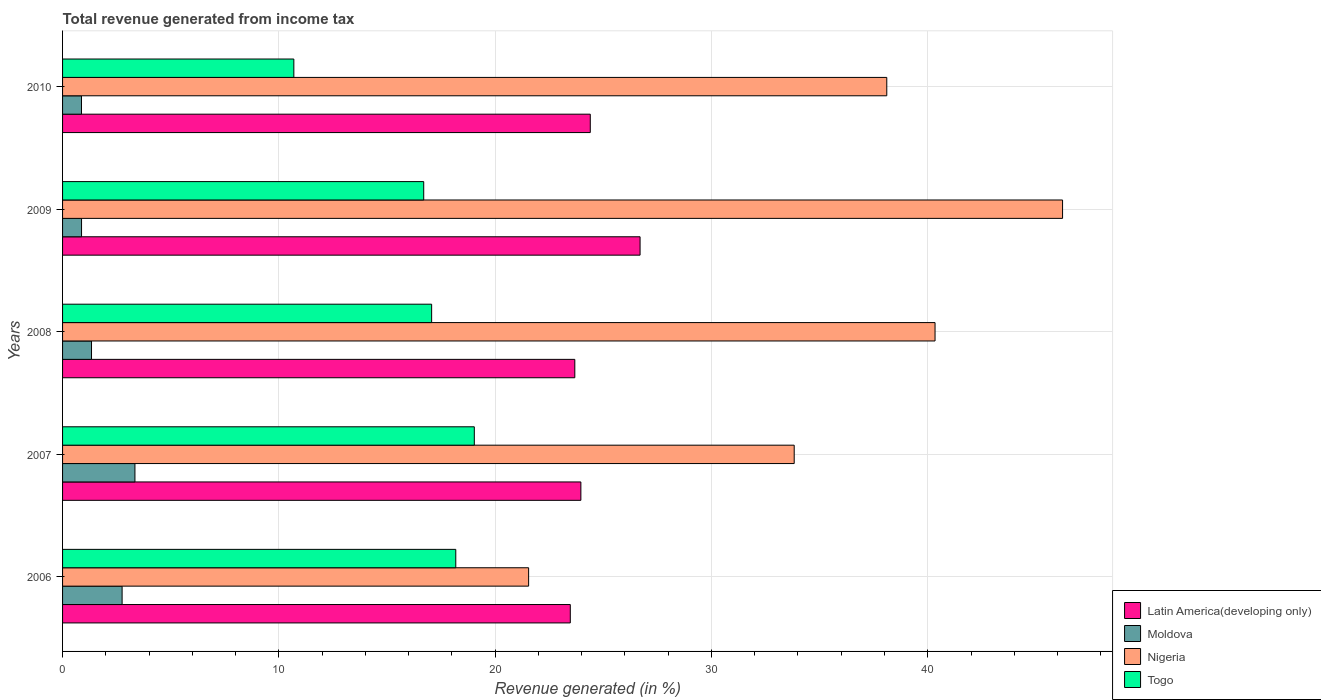How many groups of bars are there?
Your answer should be very brief. 5. Are the number of bars per tick equal to the number of legend labels?
Your answer should be compact. Yes. Are the number of bars on each tick of the Y-axis equal?
Your answer should be very brief. Yes. What is the label of the 1st group of bars from the top?
Keep it short and to the point. 2010. In how many cases, is the number of bars for a given year not equal to the number of legend labels?
Keep it short and to the point. 0. What is the total revenue generated in Nigeria in 2007?
Offer a terse response. 33.83. Across all years, what is the maximum total revenue generated in Latin America(developing only)?
Your answer should be very brief. 26.7. Across all years, what is the minimum total revenue generated in Togo?
Ensure brevity in your answer.  10.69. In which year was the total revenue generated in Moldova maximum?
Ensure brevity in your answer.  2007. What is the total total revenue generated in Moldova in the graph?
Provide a succinct answer. 9.19. What is the difference between the total revenue generated in Latin America(developing only) in 2007 and that in 2008?
Make the answer very short. 0.28. What is the difference between the total revenue generated in Moldova in 2008 and the total revenue generated in Togo in 2007?
Make the answer very short. -17.7. What is the average total revenue generated in Nigeria per year?
Offer a very short reply. 36.01. In the year 2006, what is the difference between the total revenue generated in Moldova and total revenue generated in Latin America(developing only)?
Make the answer very short. -20.72. In how many years, is the total revenue generated in Nigeria greater than 26 %?
Ensure brevity in your answer.  4. What is the ratio of the total revenue generated in Moldova in 2006 to that in 2007?
Offer a very short reply. 0.82. What is the difference between the highest and the second highest total revenue generated in Moldova?
Ensure brevity in your answer.  0.59. What is the difference between the highest and the lowest total revenue generated in Nigeria?
Offer a terse response. 24.69. Is it the case that in every year, the sum of the total revenue generated in Togo and total revenue generated in Latin America(developing only) is greater than the sum of total revenue generated in Moldova and total revenue generated in Nigeria?
Offer a very short reply. No. What does the 4th bar from the top in 2008 represents?
Ensure brevity in your answer.  Latin America(developing only). What does the 1st bar from the bottom in 2009 represents?
Ensure brevity in your answer.  Latin America(developing only). Is it the case that in every year, the sum of the total revenue generated in Moldova and total revenue generated in Nigeria is greater than the total revenue generated in Latin America(developing only)?
Offer a very short reply. Yes. How many bars are there?
Offer a very short reply. 20. Are all the bars in the graph horizontal?
Keep it short and to the point. Yes. Does the graph contain any zero values?
Provide a succinct answer. No. Where does the legend appear in the graph?
Keep it short and to the point. Bottom right. What is the title of the graph?
Your answer should be compact. Total revenue generated from income tax. Does "West Bank and Gaza" appear as one of the legend labels in the graph?
Make the answer very short. No. What is the label or title of the X-axis?
Offer a terse response. Revenue generated (in %). What is the label or title of the Y-axis?
Keep it short and to the point. Years. What is the Revenue generated (in %) of Latin America(developing only) in 2006?
Provide a short and direct response. 23.47. What is the Revenue generated (in %) in Moldova in 2006?
Offer a very short reply. 2.75. What is the Revenue generated (in %) in Nigeria in 2006?
Keep it short and to the point. 21.55. What is the Revenue generated (in %) of Togo in 2006?
Your answer should be very brief. 18.18. What is the Revenue generated (in %) in Latin America(developing only) in 2007?
Offer a terse response. 23.96. What is the Revenue generated (in %) in Moldova in 2007?
Ensure brevity in your answer.  3.35. What is the Revenue generated (in %) of Nigeria in 2007?
Your answer should be very brief. 33.83. What is the Revenue generated (in %) of Togo in 2007?
Offer a very short reply. 19.04. What is the Revenue generated (in %) of Latin America(developing only) in 2008?
Your response must be concise. 23.68. What is the Revenue generated (in %) in Moldova in 2008?
Your response must be concise. 1.34. What is the Revenue generated (in %) in Nigeria in 2008?
Make the answer very short. 40.34. What is the Revenue generated (in %) in Togo in 2008?
Offer a terse response. 17.06. What is the Revenue generated (in %) of Latin America(developing only) in 2009?
Your answer should be very brief. 26.7. What is the Revenue generated (in %) of Moldova in 2009?
Keep it short and to the point. 0.88. What is the Revenue generated (in %) in Nigeria in 2009?
Your answer should be very brief. 46.23. What is the Revenue generated (in %) of Togo in 2009?
Make the answer very short. 16.7. What is the Revenue generated (in %) in Latin America(developing only) in 2010?
Offer a very short reply. 24.4. What is the Revenue generated (in %) of Moldova in 2010?
Your response must be concise. 0.87. What is the Revenue generated (in %) of Nigeria in 2010?
Ensure brevity in your answer.  38.11. What is the Revenue generated (in %) in Togo in 2010?
Offer a terse response. 10.69. Across all years, what is the maximum Revenue generated (in %) in Latin America(developing only)?
Ensure brevity in your answer.  26.7. Across all years, what is the maximum Revenue generated (in %) in Moldova?
Provide a short and direct response. 3.35. Across all years, what is the maximum Revenue generated (in %) of Nigeria?
Provide a succinct answer. 46.23. Across all years, what is the maximum Revenue generated (in %) in Togo?
Give a very brief answer. 19.04. Across all years, what is the minimum Revenue generated (in %) in Latin America(developing only)?
Provide a succinct answer. 23.47. Across all years, what is the minimum Revenue generated (in %) in Moldova?
Your response must be concise. 0.87. Across all years, what is the minimum Revenue generated (in %) in Nigeria?
Make the answer very short. 21.55. Across all years, what is the minimum Revenue generated (in %) of Togo?
Offer a very short reply. 10.69. What is the total Revenue generated (in %) of Latin America(developing only) in the graph?
Your response must be concise. 122.22. What is the total Revenue generated (in %) of Moldova in the graph?
Provide a short and direct response. 9.19. What is the total Revenue generated (in %) of Nigeria in the graph?
Offer a very short reply. 180.05. What is the total Revenue generated (in %) in Togo in the graph?
Provide a succinct answer. 81.67. What is the difference between the Revenue generated (in %) in Latin America(developing only) in 2006 and that in 2007?
Provide a succinct answer. -0.49. What is the difference between the Revenue generated (in %) in Moldova in 2006 and that in 2007?
Offer a terse response. -0.59. What is the difference between the Revenue generated (in %) of Nigeria in 2006 and that in 2007?
Your answer should be compact. -12.28. What is the difference between the Revenue generated (in %) of Togo in 2006 and that in 2007?
Offer a very short reply. -0.86. What is the difference between the Revenue generated (in %) of Latin America(developing only) in 2006 and that in 2008?
Ensure brevity in your answer.  -0.21. What is the difference between the Revenue generated (in %) of Moldova in 2006 and that in 2008?
Make the answer very short. 1.41. What is the difference between the Revenue generated (in %) in Nigeria in 2006 and that in 2008?
Offer a very short reply. -18.79. What is the difference between the Revenue generated (in %) of Togo in 2006 and that in 2008?
Offer a terse response. 1.12. What is the difference between the Revenue generated (in %) in Latin America(developing only) in 2006 and that in 2009?
Your response must be concise. -3.23. What is the difference between the Revenue generated (in %) in Moldova in 2006 and that in 2009?
Keep it short and to the point. 1.88. What is the difference between the Revenue generated (in %) in Nigeria in 2006 and that in 2009?
Provide a succinct answer. -24.69. What is the difference between the Revenue generated (in %) of Togo in 2006 and that in 2009?
Your answer should be very brief. 1.48. What is the difference between the Revenue generated (in %) of Latin America(developing only) in 2006 and that in 2010?
Offer a very short reply. -0.92. What is the difference between the Revenue generated (in %) of Moldova in 2006 and that in 2010?
Make the answer very short. 1.88. What is the difference between the Revenue generated (in %) in Nigeria in 2006 and that in 2010?
Make the answer very short. -16.56. What is the difference between the Revenue generated (in %) in Togo in 2006 and that in 2010?
Keep it short and to the point. 7.49. What is the difference between the Revenue generated (in %) of Latin America(developing only) in 2007 and that in 2008?
Make the answer very short. 0.28. What is the difference between the Revenue generated (in %) in Moldova in 2007 and that in 2008?
Give a very brief answer. 2.01. What is the difference between the Revenue generated (in %) of Nigeria in 2007 and that in 2008?
Keep it short and to the point. -6.51. What is the difference between the Revenue generated (in %) of Togo in 2007 and that in 2008?
Your response must be concise. 1.97. What is the difference between the Revenue generated (in %) of Latin America(developing only) in 2007 and that in 2009?
Your response must be concise. -2.74. What is the difference between the Revenue generated (in %) in Moldova in 2007 and that in 2009?
Your answer should be compact. 2.47. What is the difference between the Revenue generated (in %) in Nigeria in 2007 and that in 2009?
Offer a very short reply. -12.41. What is the difference between the Revenue generated (in %) of Togo in 2007 and that in 2009?
Your response must be concise. 2.34. What is the difference between the Revenue generated (in %) in Latin America(developing only) in 2007 and that in 2010?
Provide a short and direct response. -0.43. What is the difference between the Revenue generated (in %) of Moldova in 2007 and that in 2010?
Your response must be concise. 2.47. What is the difference between the Revenue generated (in %) of Nigeria in 2007 and that in 2010?
Offer a very short reply. -4.28. What is the difference between the Revenue generated (in %) of Togo in 2007 and that in 2010?
Provide a succinct answer. 8.34. What is the difference between the Revenue generated (in %) in Latin America(developing only) in 2008 and that in 2009?
Provide a short and direct response. -3.02. What is the difference between the Revenue generated (in %) of Moldova in 2008 and that in 2009?
Make the answer very short. 0.46. What is the difference between the Revenue generated (in %) of Nigeria in 2008 and that in 2009?
Offer a very short reply. -5.9. What is the difference between the Revenue generated (in %) of Togo in 2008 and that in 2009?
Give a very brief answer. 0.37. What is the difference between the Revenue generated (in %) of Latin America(developing only) in 2008 and that in 2010?
Your answer should be very brief. -0.72. What is the difference between the Revenue generated (in %) in Moldova in 2008 and that in 2010?
Offer a terse response. 0.46. What is the difference between the Revenue generated (in %) in Nigeria in 2008 and that in 2010?
Keep it short and to the point. 2.23. What is the difference between the Revenue generated (in %) in Togo in 2008 and that in 2010?
Provide a short and direct response. 6.37. What is the difference between the Revenue generated (in %) of Latin America(developing only) in 2009 and that in 2010?
Offer a very short reply. 2.3. What is the difference between the Revenue generated (in %) in Moldova in 2009 and that in 2010?
Make the answer very short. 0. What is the difference between the Revenue generated (in %) of Nigeria in 2009 and that in 2010?
Your response must be concise. 8.13. What is the difference between the Revenue generated (in %) of Togo in 2009 and that in 2010?
Provide a succinct answer. 6. What is the difference between the Revenue generated (in %) in Latin America(developing only) in 2006 and the Revenue generated (in %) in Moldova in 2007?
Offer a terse response. 20.13. What is the difference between the Revenue generated (in %) in Latin America(developing only) in 2006 and the Revenue generated (in %) in Nigeria in 2007?
Offer a terse response. -10.35. What is the difference between the Revenue generated (in %) of Latin America(developing only) in 2006 and the Revenue generated (in %) of Togo in 2007?
Provide a short and direct response. 4.44. What is the difference between the Revenue generated (in %) of Moldova in 2006 and the Revenue generated (in %) of Nigeria in 2007?
Your response must be concise. -31.07. What is the difference between the Revenue generated (in %) in Moldova in 2006 and the Revenue generated (in %) in Togo in 2007?
Provide a succinct answer. -16.28. What is the difference between the Revenue generated (in %) in Nigeria in 2006 and the Revenue generated (in %) in Togo in 2007?
Keep it short and to the point. 2.51. What is the difference between the Revenue generated (in %) in Latin America(developing only) in 2006 and the Revenue generated (in %) in Moldova in 2008?
Ensure brevity in your answer.  22.14. What is the difference between the Revenue generated (in %) of Latin America(developing only) in 2006 and the Revenue generated (in %) of Nigeria in 2008?
Your answer should be compact. -16.86. What is the difference between the Revenue generated (in %) in Latin America(developing only) in 2006 and the Revenue generated (in %) in Togo in 2008?
Provide a succinct answer. 6.41. What is the difference between the Revenue generated (in %) of Moldova in 2006 and the Revenue generated (in %) of Nigeria in 2008?
Give a very brief answer. -37.59. What is the difference between the Revenue generated (in %) in Moldova in 2006 and the Revenue generated (in %) in Togo in 2008?
Give a very brief answer. -14.31. What is the difference between the Revenue generated (in %) in Nigeria in 2006 and the Revenue generated (in %) in Togo in 2008?
Ensure brevity in your answer.  4.48. What is the difference between the Revenue generated (in %) in Latin America(developing only) in 2006 and the Revenue generated (in %) in Moldova in 2009?
Make the answer very short. 22.6. What is the difference between the Revenue generated (in %) of Latin America(developing only) in 2006 and the Revenue generated (in %) of Nigeria in 2009?
Ensure brevity in your answer.  -22.76. What is the difference between the Revenue generated (in %) of Latin America(developing only) in 2006 and the Revenue generated (in %) of Togo in 2009?
Your response must be concise. 6.78. What is the difference between the Revenue generated (in %) of Moldova in 2006 and the Revenue generated (in %) of Nigeria in 2009?
Your response must be concise. -43.48. What is the difference between the Revenue generated (in %) in Moldova in 2006 and the Revenue generated (in %) in Togo in 2009?
Provide a short and direct response. -13.94. What is the difference between the Revenue generated (in %) in Nigeria in 2006 and the Revenue generated (in %) in Togo in 2009?
Keep it short and to the point. 4.85. What is the difference between the Revenue generated (in %) of Latin America(developing only) in 2006 and the Revenue generated (in %) of Moldova in 2010?
Give a very brief answer. 22.6. What is the difference between the Revenue generated (in %) in Latin America(developing only) in 2006 and the Revenue generated (in %) in Nigeria in 2010?
Your answer should be very brief. -14.63. What is the difference between the Revenue generated (in %) in Latin America(developing only) in 2006 and the Revenue generated (in %) in Togo in 2010?
Offer a terse response. 12.78. What is the difference between the Revenue generated (in %) of Moldova in 2006 and the Revenue generated (in %) of Nigeria in 2010?
Give a very brief answer. -35.35. What is the difference between the Revenue generated (in %) in Moldova in 2006 and the Revenue generated (in %) in Togo in 2010?
Provide a short and direct response. -7.94. What is the difference between the Revenue generated (in %) of Nigeria in 2006 and the Revenue generated (in %) of Togo in 2010?
Ensure brevity in your answer.  10.85. What is the difference between the Revenue generated (in %) in Latin America(developing only) in 2007 and the Revenue generated (in %) in Moldova in 2008?
Offer a terse response. 22.63. What is the difference between the Revenue generated (in %) in Latin America(developing only) in 2007 and the Revenue generated (in %) in Nigeria in 2008?
Give a very brief answer. -16.37. What is the difference between the Revenue generated (in %) in Moldova in 2007 and the Revenue generated (in %) in Nigeria in 2008?
Your answer should be compact. -36.99. What is the difference between the Revenue generated (in %) in Moldova in 2007 and the Revenue generated (in %) in Togo in 2008?
Offer a very short reply. -13.72. What is the difference between the Revenue generated (in %) in Nigeria in 2007 and the Revenue generated (in %) in Togo in 2008?
Make the answer very short. 16.76. What is the difference between the Revenue generated (in %) of Latin America(developing only) in 2007 and the Revenue generated (in %) of Moldova in 2009?
Give a very brief answer. 23.09. What is the difference between the Revenue generated (in %) of Latin America(developing only) in 2007 and the Revenue generated (in %) of Nigeria in 2009?
Provide a succinct answer. -22.27. What is the difference between the Revenue generated (in %) of Latin America(developing only) in 2007 and the Revenue generated (in %) of Togo in 2009?
Offer a terse response. 7.27. What is the difference between the Revenue generated (in %) of Moldova in 2007 and the Revenue generated (in %) of Nigeria in 2009?
Offer a terse response. -42.89. What is the difference between the Revenue generated (in %) in Moldova in 2007 and the Revenue generated (in %) in Togo in 2009?
Keep it short and to the point. -13.35. What is the difference between the Revenue generated (in %) in Nigeria in 2007 and the Revenue generated (in %) in Togo in 2009?
Offer a very short reply. 17.13. What is the difference between the Revenue generated (in %) of Latin America(developing only) in 2007 and the Revenue generated (in %) of Moldova in 2010?
Provide a succinct answer. 23.09. What is the difference between the Revenue generated (in %) in Latin America(developing only) in 2007 and the Revenue generated (in %) in Nigeria in 2010?
Ensure brevity in your answer.  -14.14. What is the difference between the Revenue generated (in %) of Latin America(developing only) in 2007 and the Revenue generated (in %) of Togo in 2010?
Your response must be concise. 13.27. What is the difference between the Revenue generated (in %) in Moldova in 2007 and the Revenue generated (in %) in Nigeria in 2010?
Your answer should be very brief. -34.76. What is the difference between the Revenue generated (in %) of Moldova in 2007 and the Revenue generated (in %) of Togo in 2010?
Provide a succinct answer. -7.35. What is the difference between the Revenue generated (in %) in Nigeria in 2007 and the Revenue generated (in %) in Togo in 2010?
Your answer should be compact. 23.13. What is the difference between the Revenue generated (in %) of Latin America(developing only) in 2008 and the Revenue generated (in %) of Moldova in 2009?
Keep it short and to the point. 22.81. What is the difference between the Revenue generated (in %) in Latin America(developing only) in 2008 and the Revenue generated (in %) in Nigeria in 2009?
Your answer should be compact. -22.55. What is the difference between the Revenue generated (in %) of Latin America(developing only) in 2008 and the Revenue generated (in %) of Togo in 2009?
Keep it short and to the point. 6.99. What is the difference between the Revenue generated (in %) of Moldova in 2008 and the Revenue generated (in %) of Nigeria in 2009?
Ensure brevity in your answer.  -44.89. What is the difference between the Revenue generated (in %) in Moldova in 2008 and the Revenue generated (in %) in Togo in 2009?
Offer a very short reply. -15.36. What is the difference between the Revenue generated (in %) of Nigeria in 2008 and the Revenue generated (in %) of Togo in 2009?
Provide a short and direct response. 23.64. What is the difference between the Revenue generated (in %) of Latin America(developing only) in 2008 and the Revenue generated (in %) of Moldova in 2010?
Offer a very short reply. 22.81. What is the difference between the Revenue generated (in %) in Latin America(developing only) in 2008 and the Revenue generated (in %) in Nigeria in 2010?
Offer a terse response. -14.42. What is the difference between the Revenue generated (in %) of Latin America(developing only) in 2008 and the Revenue generated (in %) of Togo in 2010?
Offer a terse response. 12.99. What is the difference between the Revenue generated (in %) in Moldova in 2008 and the Revenue generated (in %) in Nigeria in 2010?
Provide a short and direct response. -36.77. What is the difference between the Revenue generated (in %) in Moldova in 2008 and the Revenue generated (in %) in Togo in 2010?
Your answer should be compact. -9.35. What is the difference between the Revenue generated (in %) of Nigeria in 2008 and the Revenue generated (in %) of Togo in 2010?
Keep it short and to the point. 29.65. What is the difference between the Revenue generated (in %) in Latin America(developing only) in 2009 and the Revenue generated (in %) in Moldova in 2010?
Ensure brevity in your answer.  25.83. What is the difference between the Revenue generated (in %) of Latin America(developing only) in 2009 and the Revenue generated (in %) of Nigeria in 2010?
Ensure brevity in your answer.  -11.41. What is the difference between the Revenue generated (in %) of Latin America(developing only) in 2009 and the Revenue generated (in %) of Togo in 2010?
Make the answer very short. 16.01. What is the difference between the Revenue generated (in %) of Moldova in 2009 and the Revenue generated (in %) of Nigeria in 2010?
Make the answer very short. -37.23. What is the difference between the Revenue generated (in %) of Moldova in 2009 and the Revenue generated (in %) of Togo in 2010?
Your answer should be compact. -9.82. What is the difference between the Revenue generated (in %) in Nigeria in 2009 and the Revenue generated (in %) in Togo in 2010?
Provide a succinct answer. 35.54. What is the average Revenue generated (in %) in Latin America(developing only) per year?
Your response must be concise. 24.44. What is the average Revenue generated (in %) of Moldova per year?
Make the answer very short. 1.84. What is the average Revenue generated (in %) of Nigeria per year?
Offer a terse response. 36.01. What is the average Revenue generated (in %) of Togo per year?
Make the answer very short. 16.33. In the year 2006, what is the difference between the Revenue generated (in %) of Latin America(developing only) and Revenue generated (in %) of Moldova?
Provide a short and direct response. 20.72. In the year 2006, what is the difference between the Revenue generated (in %) in Latin America(developing only) and Revenue generated (in %) in Nigeria?
Offer a terse response. 1.93. In the year 2006, what is the difference between the Revenue generated (in %) in Latin America(developing only) and Revenue generated (in %) in Togo?
Offer a very short reply. 5.29. In the year 2006, what is the difference between the Revenue generated (in %) in Moldova and Revenue generated (in %) in Nigeria?
Make the answer very short. -18.79. In the year 2006, what is the difference between the Revenue generated (in %) of Moldova and Revenue generated (in %) of Togo?
Give a very brief answer. -15.43. In the year 2006, what is the difference between the Revenue generated (in %) in Nigeria and Revenue generated (in %) in Togo?
Give a very brief answer. 3.37. In the year 2007, what is the difference between the Revenue generated (in %) in Latin America(developing only) and Revenue generated (in %) in Moldova?
Give a very brief answer. 20.62. In the year 2007, what is the difference between the Revenue generated (in %) of Latin America(developing only) and Revenue generated (in %) of Nigeria?
Your answer should be compact. -9.86. In the year 2007, what is the difference between the Revenue generated (in %) of Latin America(developing only) and Revenue generated (in %) of Togo?
Make the answer very short. 4.93. In the year 2007, what is the difference between the Revenue generated (in %) in Moldova and Revenue generated (in %) in Nigeria?
Your answer should be very brief. -30.48. In the year 2007, what is the difference between the Revenue generated (in %) of Moldova and Revenue generated (in %) of Togo?
Provide a succinct answer. -15.69. In the year 2007, what is the difference between the Revenue generated (in %) of Nigeria and Revenue generated (in %) of Togo?
Offer a very short reply. 14.79. In the year 2008, what is the difference between the Revenue generated (in %) in Latin America(developing only) and Revenue generated (in %) in Moldova?
Your answer should be very brief. 22.34. In the year 2008, what is the difference between the Revenue generated (in %) of Latin America(developing only) and Revenue generated (in %) of Nigeria?
Your answer should be very brief. -16.66. In the year 2008, what is the difference between the Revenue generated (in %) of Latin America(developing only) and Revenue generated (in %) of Togo?
Keep it short and to the point. 6.62. In the year 2008, what is the difference between the Revenue generated (in %) of Moldova and Revenue generated (in %) of Nigeria?
Ensure brevity in your answer.  -39. In the year 2008, what is the difference between the Revenue generated (in %) of Moldova and Revenue generated (in %) of Togo?
Ensure brevity in your answer.  -15.73. In the year 2008, what is the difference between the Revenue generated (in %) of Nigeria and Revenue generated (in %) of Togo?
Provide a short and direct response. 23.27. In the year 2009, what is the difference between the Revenue generated (in %) of Latin America(developing only) and Revenue generated (in %) of Moldova?
Give a very brief answer. 25.82. In the year 2009, what is the difference between the Revenue generated (in %) of Latin America(developing only) and Revenue generated (in %) of Nigeria?
Your response must be concise. -19.53. In the year 2009, what is the difference between the Revenue generated (in %) in Latin America(developing only) and Revenue generated (in %) in Togo?
Provide a succinct answer. 10. In the year 2009, what is the difference between the Revenue generated (in %) in Moldova and Revenue generated (in %) in Nigeria?
Provide a succinct answer. -45.36. In the year 2009, what is the difference between the Revenue generated (in %) of Moldova and Revenue generated (in %) of Togo?
Give a very brief answer. -15.82. In the year 2009, what is the difference between the Revenue generated (in %) of Nigeria and Revenue generated (in %) of Togo?
Ensure brevity in your answer.  29.54. In the year 2010, what is the difference between the Revenue generated (in %) in Latin America(developing only) and Revenue generated (in %) in Moldova?
Make the answer very short. 23.52. In the year 2010, what is the difference between the Revenue generated (in %) of Latin America(developing only) and Revenue generated (in %) of Nigeria?
Ensure brevity in your answer.  -13.71. In the year 2010, what is the difference between the Revenue generated (in %) of Latin America(developing only) and Revenue generated (in %) of Togo?
Your response must be concise. 13.71. In the year 2010, what is the difference between the Revenue generated (in %) of Moldova and Revenue generated (in %) of Nigeria?
Ensure brevity in your answer.  -37.23. In the year 2010, what is the difference between the Revenue generated (in %) of Moldova and Revenue generated (in %) of Togo?
Make the answer very short. -9.82. In the year 2010, what is the difference between the Revenue generated (in %) in Nigeria and Revenue generated (in %) in Togo?
Your answer should be very brief. 27.41. What is the ratio of the Revenue generated (in %) of Latin America(developing only) in 2006 to that in 2007?
Your answer should be compact. 0.98. What is the ratio of the Revenue generated (in %) in Moldova in 2006 to that in 2007?
Offer a very short reply. 0.82. What is the ratio of the Revenue generated (in %) in Nigeria in 2006 to that in 2007?
Offer a very short reply. 0.64. What is the ratio of the Revenue generated (in %) of Togo in 2006 to that in 2007?
Make the answer very short. 0.95. What is the ratio of the Revenue generated (in %) in Latin America(developing only) in 2006 to that in 2008?
Your answer should be very brief. 0.99. What is the ratio of the Revenue generated (in %) in Moldova in 2006 to that in 2008?
Your response must be concise. 2.06. What is the ratio of the Revenue generated (in %) in Nigeria in 2006 to that in 2008?
Offer a terse response. 0.53. What is the ratio of the Revenue generated (in %) in Togo in 2006 to that in 2008?
Your response must be concise. 1.07. What is the ratio of the Revenue generated (in %) of Latin America(developing only) in 2006 to that in 2009?
Your response must be concise. 0.88. What is the ratio of the Revenue generated (in %) of Moldova in 2006 to that in 2009?
Your answer should be very brief. 3.14. What is the ratio of the Revenue generated (in %) in Nigeria in 2006 to that in 2009?
Provide a succinct answer. 0.47. What is the ratio of the Revenue generated (in %) of Togo in 2006 to that in 2009?
Make the answer very short. 1.09. What is the ratio of the Revenue generated (in %) of Latin America(developing only) in 2006 to that in 2010?
Ensure brevity in your answer.  0.96. What is the ratio of the Revenue generated (in %) of Moldova in 2006 to that in 2010?
Make the answer very short. 3.15. What is the ratio of the Revenue generated (in %) in Nigeria in 2006 to that in 2010?
Offer a terse response. 0.57. What is the ratio of the Revenue generated (in %) of Togo in 2006 to that in 2010?
Offer a very short reply. 1.7. What is the ratio of the Revenue generated (in %) in Latin America(developing only) in 2007 to that in 2008?
Ensure brevity in your answer.  1.01. What is the ratio of the Revenue generated (in %) of Moldova in 2007 to that in 2008?
Your answer should be compact. 2.5. What is the ratio of the Revenue generated (in %) of Nigeria in 2007 to that in 2008?
Provide a succinct answer. 0.84. What is the ratio of the Revenue generated (in %) of Togo in 2007 to that in 2008?
Offer a terse response. 1.12. What is the ratio of the Revenue generated (in %) of Latin America(developing only) in 2007 to that in 2009?
Your response must be concise. 0.9. What is the ratio of the Revenue generated (in %) in Moldova in 2007 to that in 2009?
Your answer should be compact. 3.81. What is the ratio of the Revenue generated (in %) of Nigeria in 2007 to that in 2009?
Offer a terse response. 0.73. What is the ratio of the Revenue generated (in %) of Togo in 2007 to that in 2009?
Ensure brevity in your answer.  1.14. What is the ratio of the Revenue generated (in %) of Latin America(developing only) in 2007 to that in 2010?
Make the answer very short. 0.98. What is the ratio of the Revenue generated (in %) of Moldova in 2007 to that in 2010?
Keep it short and to the point. 3.83. What is the ratio of the Revenue generated (in %) of Nigeria in 2007 to that in 2010?
Offer a very short reply. 0.89. What is the ratio of the Revenue generated (in %) of Togo in 2007 to that in 2010?
Your answer should be compact. 1.78. What is the ratio of the Revenue generated (in %) of Latin America(developing only) in 2008 to that in 2009?
Keep it short and to the point. 0.89. What is the ratio of the Revenue generated (in %) of Moldova in 2008 to that in 2009?
Keep it short and to the point. 1.53. What is the ratio of the Revenue generated (in %) in Nigeria in 2008 to that in 2009?
Make the answer very short. 0.87. What is the ratio of the Revenue generated (in %) of Togo in 2008 to that in 2009?
Give a very brief answer. 1.02. What is the ratio of the Revenue generated (in %) in Latin America(developing only) in 2008 to that in 2010?
Your answer should be very brief. 0.97. What is the ratio of the Revenue generated (in %) in Moldova in 2008 to that in 2010?
Ensure brevity in your answer.  1.53. What is the ratio of the Revenue generated (in %) of Nigeria in 2008 to that in 2010?
Your answer should be very brief. 1.06. What is the ratio of the Revenue generated (in %) in Togo in 2008 to that in 2010?
Your answer should be very brief. 1.6. What is the ratio of the Revenue generated (in %) of Latin America(developing only) in 2009 to that in 2010?
Offer a terse response. 1.09. What is the ratio of the Revenue generated (in %) of Moldova in 2009 to that in 2010?
Your answer should be very brief. 1. What is the ratio of the Revenue generated (in %) of Nigeria in 2009 to that in 2010?
Ensure brevity in your answer.  1.21. What is the ratio of the Revenue generated (in %) of Togo in 2009 to that in 2010?
Provide a short and direct response. 1.56. What is the difference between the highest and the second highest Revenue generated (in %) of Latin America(developing only)?
Your answer should be very brief. 2.3. What is the difference between the highest and the second highest Revenue generated (in %) of Moldova?
Your answer should be very brief. 0.59. What is the difference between the highest and the second highest Revenue generated (in %) in Nigeria?
Provide a short and direct response. 5.9. What is the difference between the highest and the second highest Revenue generated (in %) in Togo?
Ensure brevity in your answer.  0.86. What is the difference between the highest and the lowest Revenue generated (in %) of Latin America(developing only)?
Give a very brief answer. 3.23. What is the difference between the highest and the lowest Revenue generated (in %) in Moldova?
Offer a terse response. 2.47. What is the difference between the highest and the lowest Revenue generated (in %) of Nigeria?
Your answer should be very brief. 24.69. What is the difference between the highest and the lowest Revenue generated (in %) of Togo?
Offer a terse response. 8.34. 